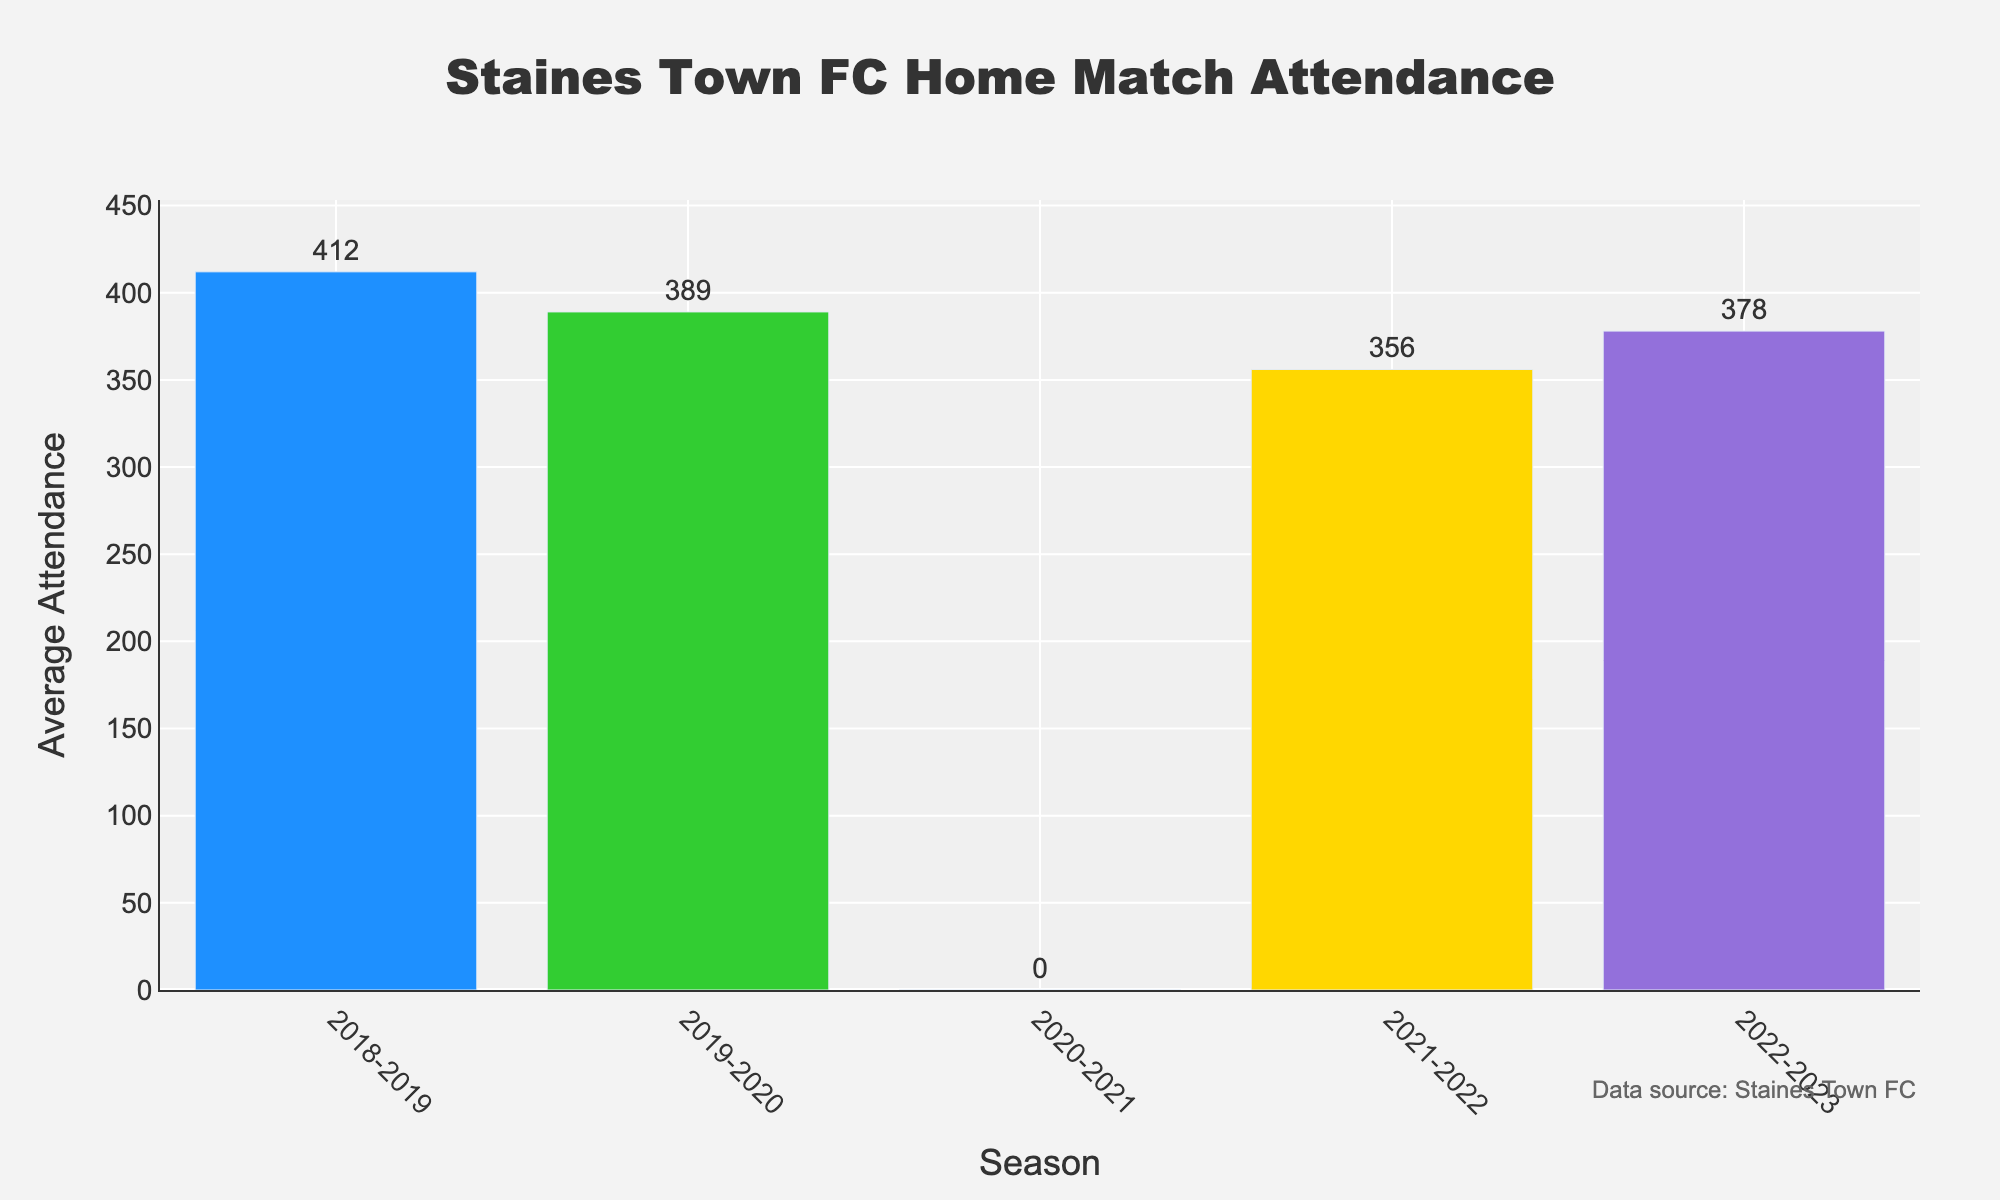What's the title of the plot? The title of the plot is mentioned at the top center of the figure. It reads "Staines Town FC Home Match Attendance."
Answer: Staines Town FC Home Match Attendance What does the y-axis represent? The y-axis represents the "Average Attendance" for Staines Town FC home matches for each season.
Answer: Average Attendance What is the average attendance for the 2020-2021 season? By referring to the bar labeled for the 2020-2021 season, the attendance value mentioned is 0.
Answer: 0 Which season had the highest average attendance? By comparing the heights of the bars, the 2018-2019 season had the highest average attendance at 412.
Answer: 2018-2019 How much did the average attendance decrease from the 2018-2019 season to the 2019-2020 season? The average attendance in 2018-2019 was 412 and in 2019-2020 it was 389. The decrease is 412 - 389 = 23.
Answer: 23 What's the total average attendance over the five seasons? Summing up the attendance for each season: 412 + 389 + 0 + 356 + 378 = 1535.
Answer: 1535 Which seasons experienced a decline in average attendance? Comparing consecutive seasons, 2018-2019 to 2019-2020 (412 to 389) and 2019-2020 to 2020-2021 (389 to 0) experienced declines.
Answer: 2018-2019 to 2019-2020, 2019-2020 to 2020-2021 How does the average attendance in the 2022-2023 season compare to the 2021-2022 season? The average attendance for 2021-2022 was 356, while for 2022-2023 it was 378. Therefore, the attendance increased from 2021-2022 to 2022-2023 (378 - 356 = 22).
Answer: Increased by 22 What's the average attendance across the seasons excluding the 2020-2021 season? Summing the attendances excluding 2020-2021: 412 + 389 + 356 + 378 = 1535. There are 4 seasons in total, so the average is 1535 / 4 = 383.75.
Answer: 383.75 What color is used to represent the 2018-2019 season? The bar for the 2018-2019 season is colored in blue.
Answer: Blue 